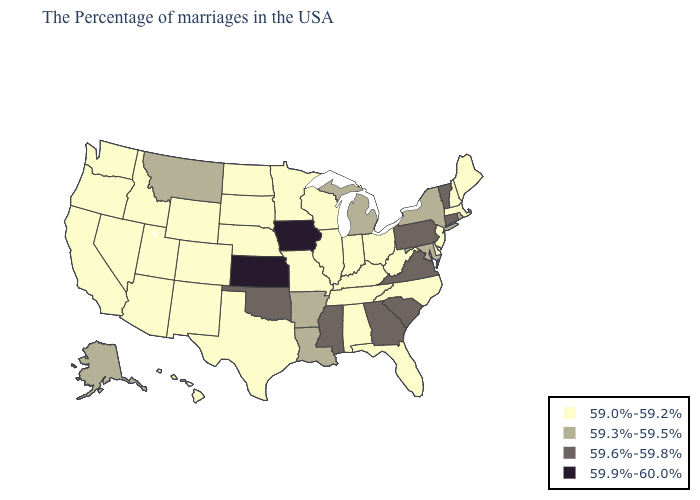Does Montana have the lowest value in the West?
Write a very short answer. No. Which states have the lowest value in the USA?
Write a very short answer. Maine, Massachusetts, New Hampshire, New Jersey, Delaware, North Carolina, West Virginia, Ohio, Florida, Kentucky, Indiana, Alabama, Tennessee, Wisconsin, Illinois, Missouri, Minnesota, Nebraska, Texas, South Dakota, North Dakota, Wyoming, Colorado, New Mexico, Utah, Arizona, Idaho, Nevada, California, Washington, Oregon, Hawaii. Which states have the highest value in the USA?
Write a very short answer. Iowa, Kansas. What is the value of Nebraska?
Concise answer only. 59.0%-59.2%. Does Iowa have the lowest value in the MidWest?
Short answer required. No. Is the legend a continuous bar?
Write a very short answer. No. Is the legend a continuous bar?
Keep it brief. No. Name the states that have a value in the range 59.6%-59.8%?
Answer briefly. Vermont, Connecticut, Pennsylvania, Virginia, South Carolina, Georgia, Mississippi, Oklahoma. What is the lowest value in the USA?
Short answer required. 59.0%-59.2%. What is the value of North Dakota?
Short answer required. 59.0%-59.2%. Does the first symbol in the legend represent the smallest category?
Answer briefly. Yes. What is the lowest value in states that border Wyoming?
Write a very short answer. 59.0%-59.2%. Name the states that have a value in the range 59.6%-59.8%?
Concise answer only. Vermont, Connecticut, Pennsylvania, Virginia, South Carolina, Georgia, Mississippi, Oklahoma. What is the lowest value in the USA?
Quick response, please. 59.0%-59.2%. 